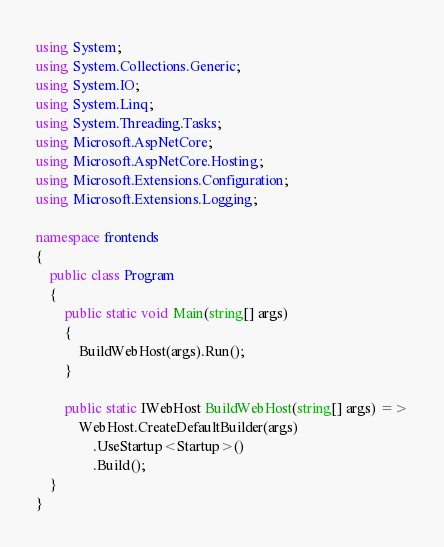<code> <loc_0><loc_0><loc_500><loc_500><_C#_>using System;
using System.Collections.Generic;
using System.IO;
using System.Linq;
using System.Threading.Tasks;
using Microsoft.AspNetCore;
using Microsoft.AspNetCore.Hosting;
using Microsoft.Extensions.Configuration;
using Microsoft.Extensions.Logging;

namespace frontends
{
    public class Program
    {
        public static void Main(string[] args)
        {
            BuildWebHost(args).Run();
        }

        public static IWebHost BuildWebHost(string[] args) =>
            WebHost.CreateDefaultBuilder(args)
                .UseStartup<Startup>()
                .Build();
    }
}
</code> 